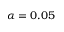<formula> <loc_0><loc_0><loc_500><loc_500>\alpha = 0 . 0 5</formula> 